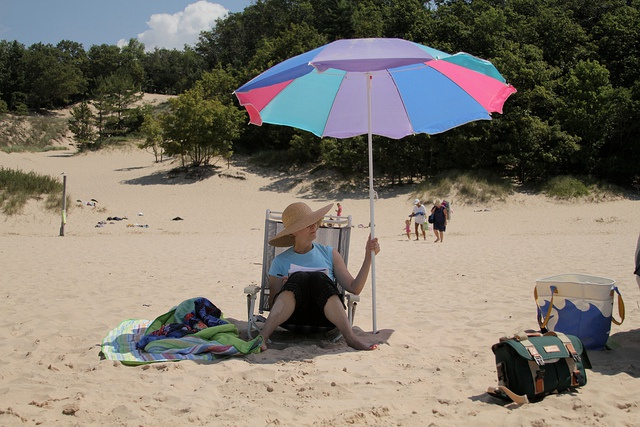Describe the objects in this image and their specific colors. I can see umbrella in gray, lightblue, darkgray, and lightpink tones, chair in gray, black, and darkgray tones, people in gray and black tones, handbag in gray, black, maroon, and tan tones, and backpack in gray, black, and maroon tones in this image. 